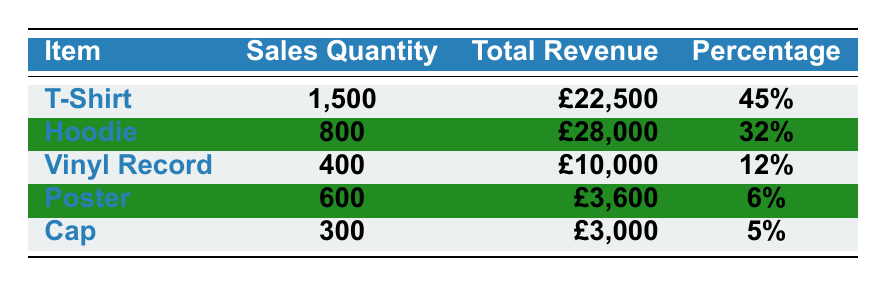What item had the highest sales quantity? By looking at the "Sales Quantity" column, the T-Shirt has the highest value, with a quantity of 1,500.
Answer: T-Shirt What is the total revenue from Hoodie sales? The "Total Revenue" for Hoodies is listed directly in the table as £28,000.
Answer: £28,000 What percentage of total sales did the Vinyl Record account for? The "Percentage" column shows that the Vinyl Record accounted for 12% of total sales.
Answer: 12% How many more T-Shirts were sold than Caps? T-Shirt sales are 1,500 and Cap sales are 300. The difference is 1,500 - 300 = 1,200.
Answer: 1,200 What is the combined revenue from Posters and Caps? The revenue for Posters is £3,600 and for Caps is £3,000. Adding them together gives £3,600 + £3,000 = £6,600.
Answer: £6,600 Is the sales quantity of Hoodies greater than the quantity of Vinyl Records and Caps combined? Hoodies sold 800, Vinyl Records sold 400, and Caps sold 300. The total for Vinyl Records and Caps is 400 + 300 = 700. Since 800 > 700, the statement is true.
Answer: Yes What is the average sales quantity of all items sold? Add all sales quantities: 1,500 + 800 + 400 + 600 + 300 = 3,600. Then divide by the number of items (5): 3,600 / 5 = 720.
Answer: 720 Which item contributed the least to the total revenue and what was the amount? The lowest value in the "Total Revenue" column is for Caps at £3,000.
Answer: Caps, £3,000 If all items were sold for a flat rate of £10 each, how much revenue would that generate in total? If each item sold was £10, considering total sales quantity of 3,600, the revenue would be 3,600 * £10 = £36,000.
Answer: £36,000 What proportion of the total merchandise sales does the T-Shirt represent in revenue? Total revenue can be calculated as £22,500 (T-Shirt) + £28,000 (Hoodie) + £10,000 (Vinyl) + £3,600 (Poster) + £3,000 (Cap) = £77,100. The proportion is £22,500 / £77,100 ≈ 29.2%.
Answer: 29.2% 